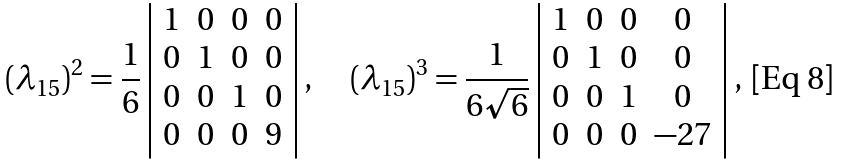<formula> <loc_0><loc_0><loc_500><loc_500>( \lambda _ { 1 5 } ) ^ { 2 } = \frac { 1 } { 6 } \left | \begin{array} { c c c c } 1 & 0 & 0 & 0 \\ 0 & 1 & 0 & 0 \\ 0 & 0 & 1 & 0 \\ 0 & 0 & 0 & 9 \end{array} \right | , \quad ( \lambda _ { 1 5 } ) ^ { 3 } = \frac { 1 } { 6 \sqrt { 6 } } \left | \begin{array} { c c c c } 1 & 0 & 0 & 0 \\ 0 & 1 & 0 & 0 \\ 0 & 0 & 1 & 0 \\ 0 & 0 & 0 & - 2 7 \end{array} \right | ,</formula> 